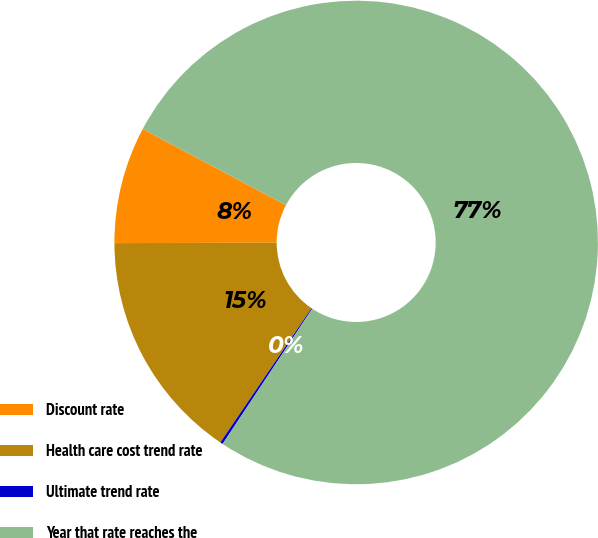Convert chart to OTSL. <chart><loc_0><loc_0><loc_500><loc_500><pie_chart><fcel>Discount rate<fcel>Health care cost trend rate<fcel>Ultimate trend rate<fcel>Year that rate reaches the<nl><fcel>7.82%<fcel>15.46%<fcel>0.18%<fcel>76.54%<nl></chart> 